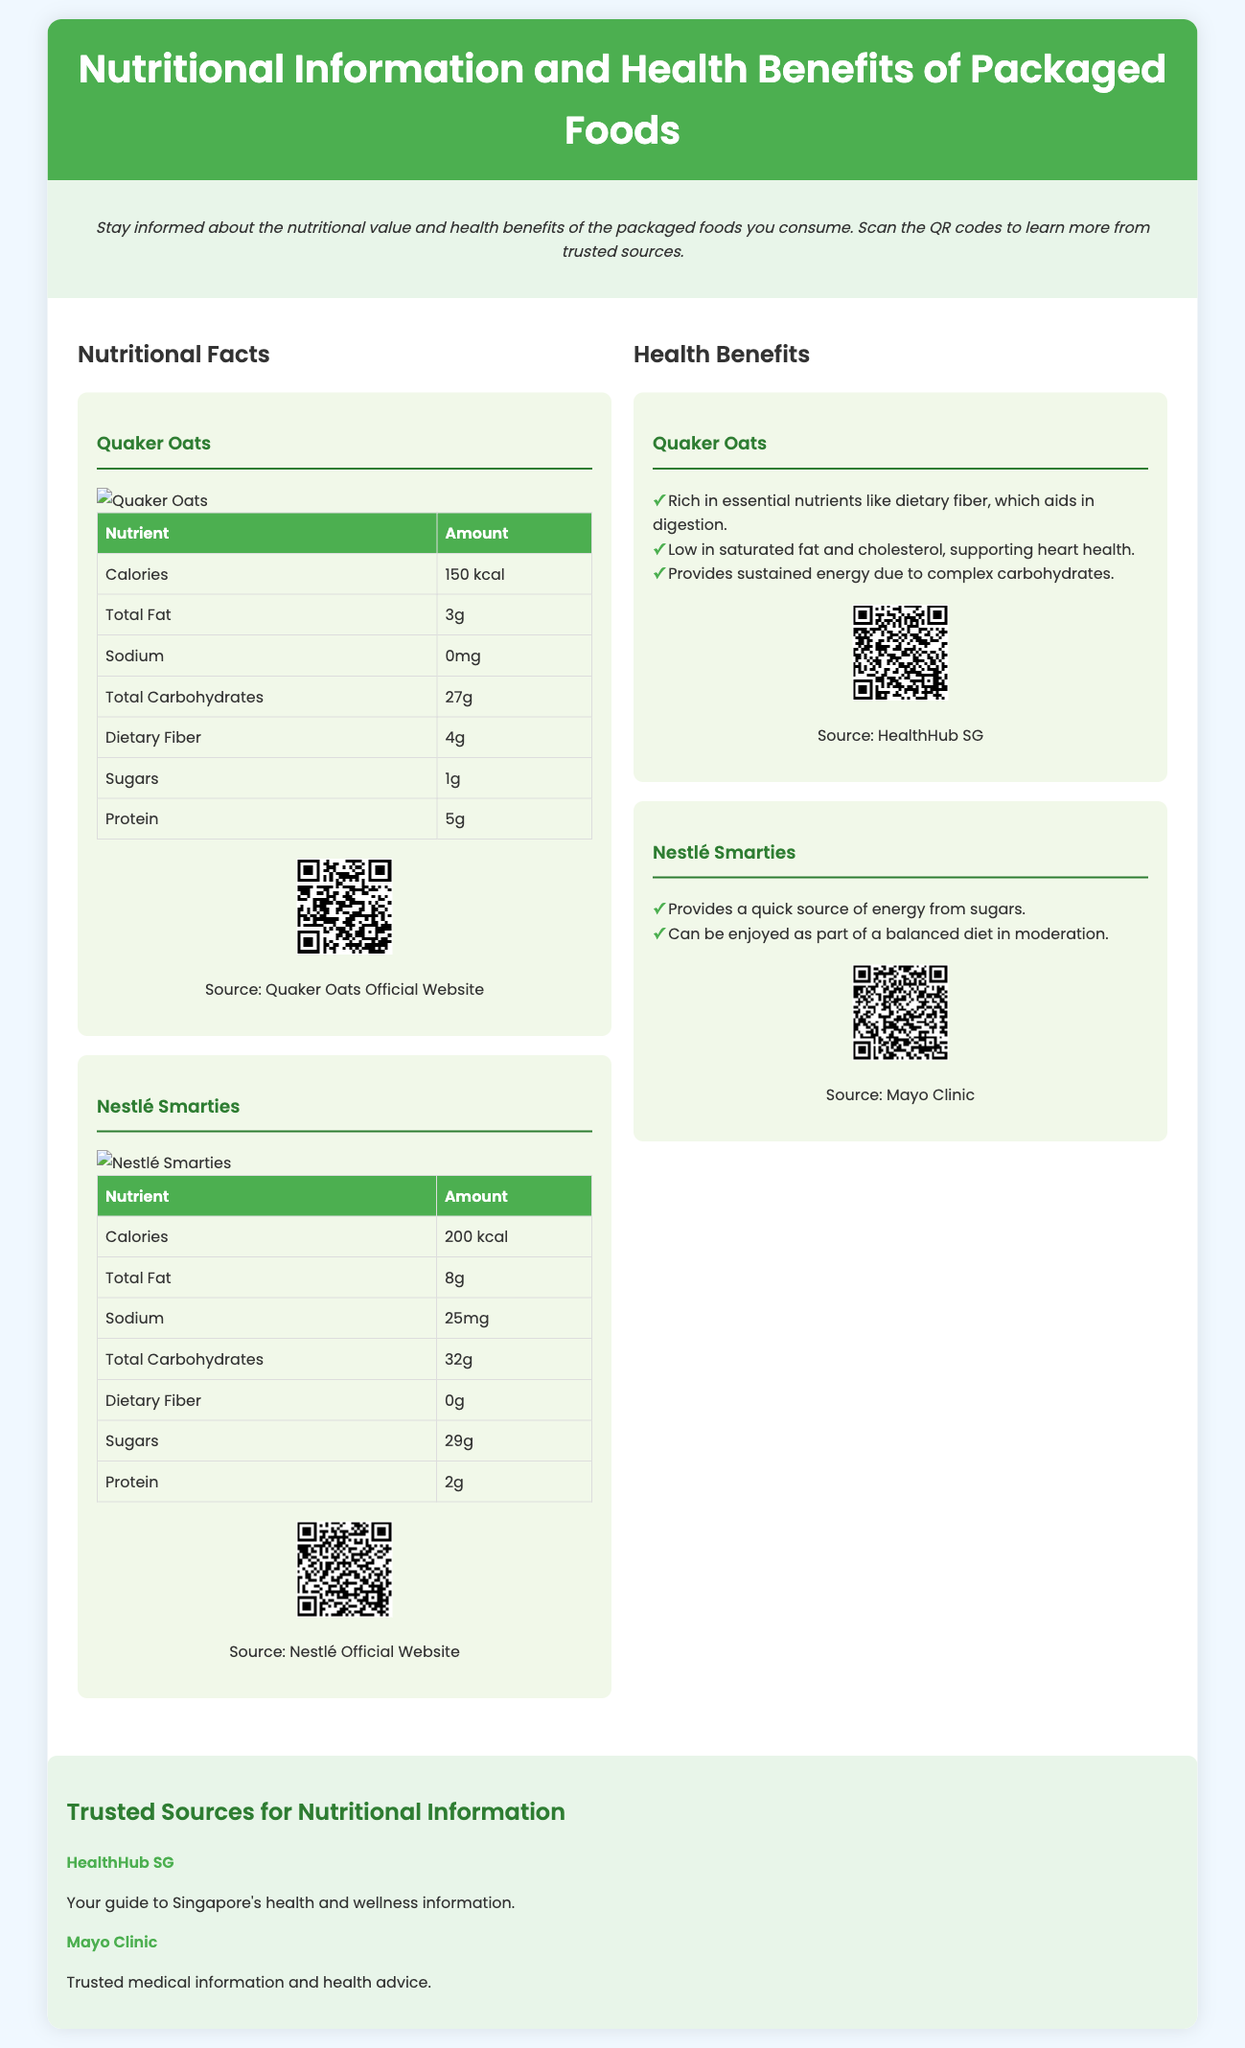What is the total calories in Quaker Oats? The document states that Quaker Oats contains 150 kcal of calories.
Answer: 150 kcal What is the amount of dietary fiber in Nestlé Smarties? According to the nutritional table, Nestlé Smarties contains 0g of dietary fiber.
Answer: 0g What is the source quoted for Quaker Oats health benefits? The health benefits for Quaker Oats mention HealthHub SG as the source.
Answer: HealthHub SG How much total fat is found in Quaker Oats? The nutritional facts indicate that Quaker Oats contains 3g of total fat.
Answer: 3g What are the key health benefits of Quaker Oats? The document lists three health benefits of Quaker Oats related to digestion, heart health, and energy.
Answer: Three What is the total carbohydrates amount in Nestlé Smarties? The nutritional information shows that Nestlé Smarties has 32g of total carbohydrates.
Answer: 32g What QR code links to the Mayo Clinic? The QR code under Nestlé Smarties links to a source that is the Mayo Clinic.
Answer: Mayo Clinic What two organizations are listed as trusted sources for nutritional information? The document mentions HealthHub SG and Mayo Clinic as trusted sources.
Answer: HealthHub SG and Mayo Clinic What is one benefit of consuming Nestlé Smarties? The benefits list states that Nestlé Smarties provides a quick source of energy from sugars.
Answer: Quick source of energy 